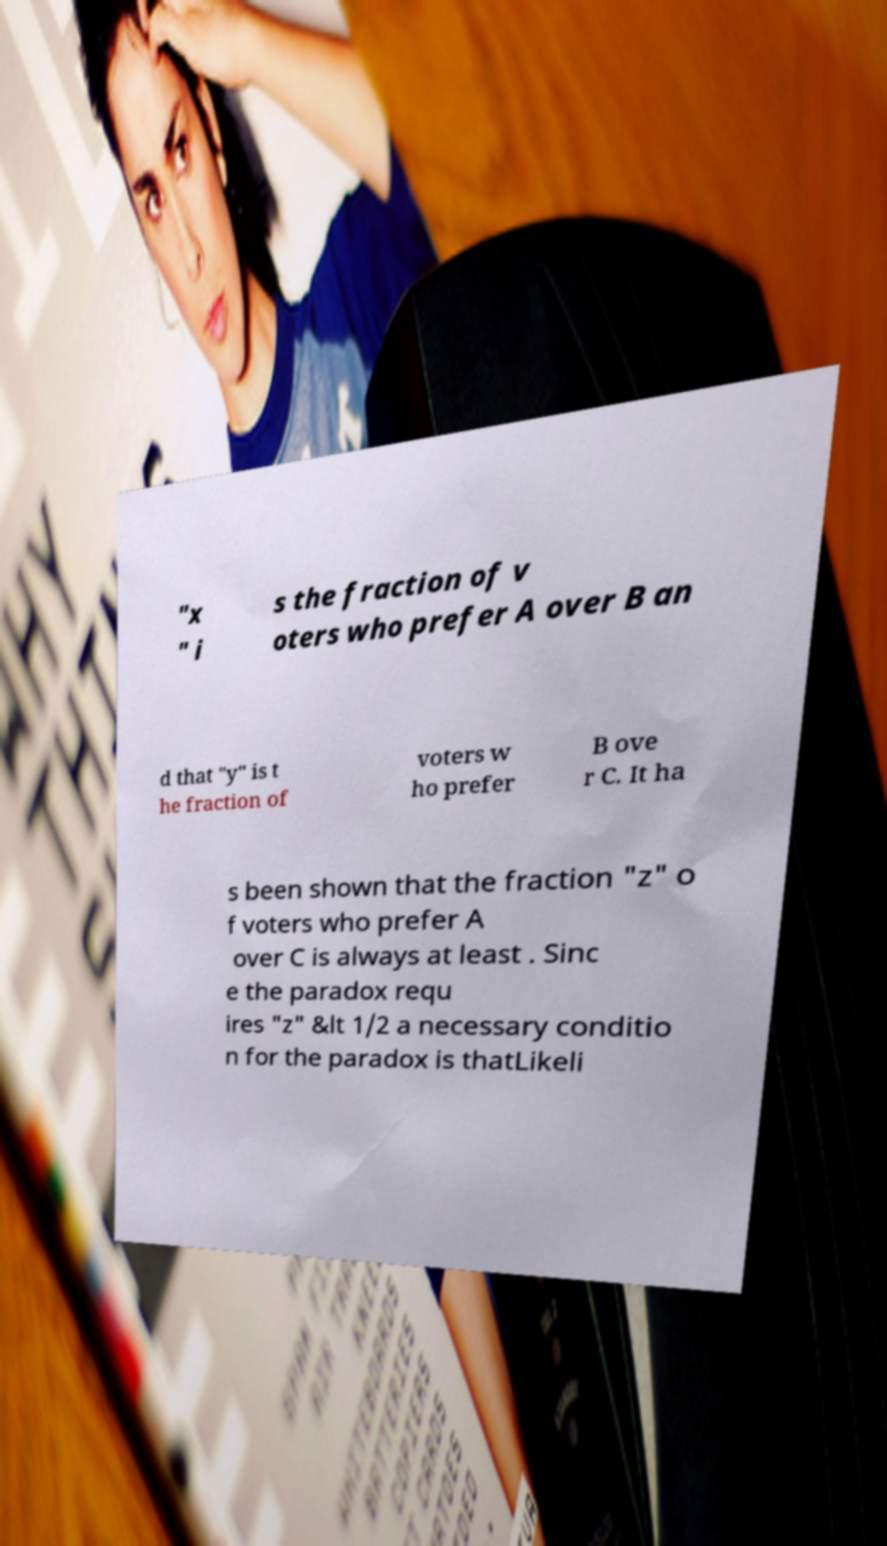Please identify and transcribe the text found in this image. "x " i s the fraction of v oters who prefer A over B an d that "y" is t he fraction of voters w ho prefer B ove r C. It ha s been shown that the fraction "z" o f voters who prefer A over C is always at least . Sinc e the paradox requ ires "z" &lt 1/2 a necessary conditio n for the paradox is thatLikeli 